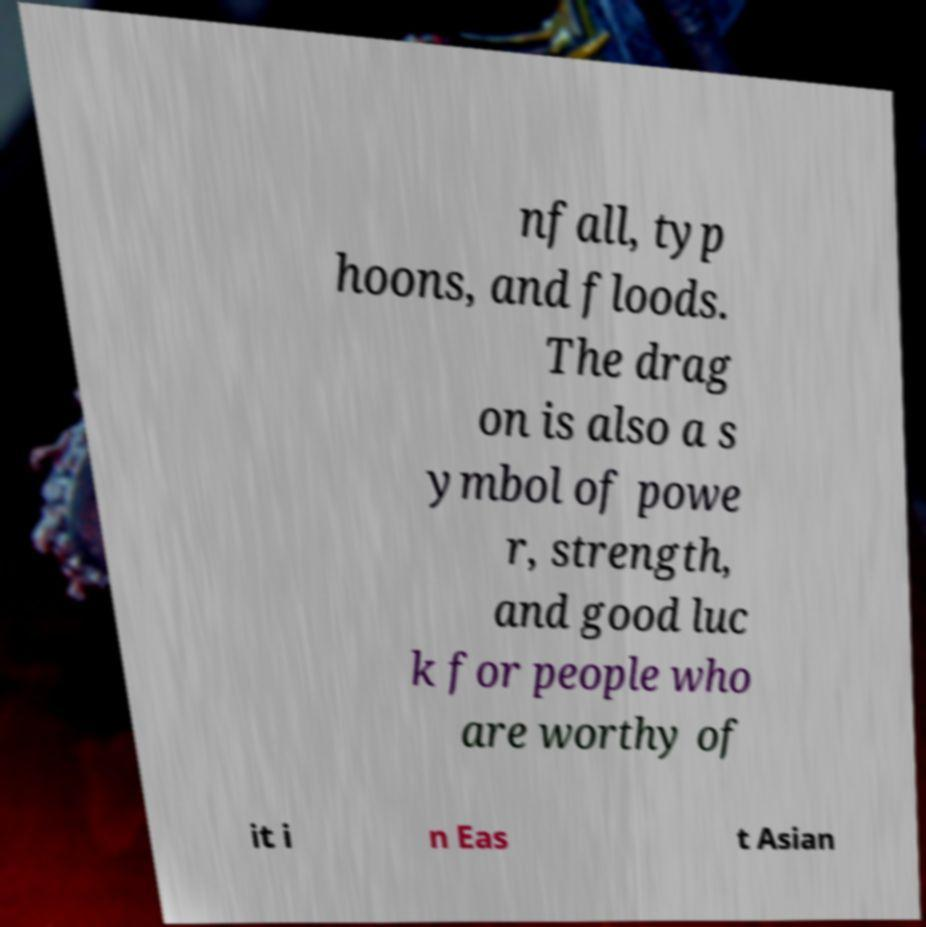For documentation purposes, I need the text within this image transcribed. Could you provide that? nfall, typ hoons, and floods. The drag on is also a s ymbol of powe r, strength, and good luc k for people who are worthy of it i n Eas t Asian 